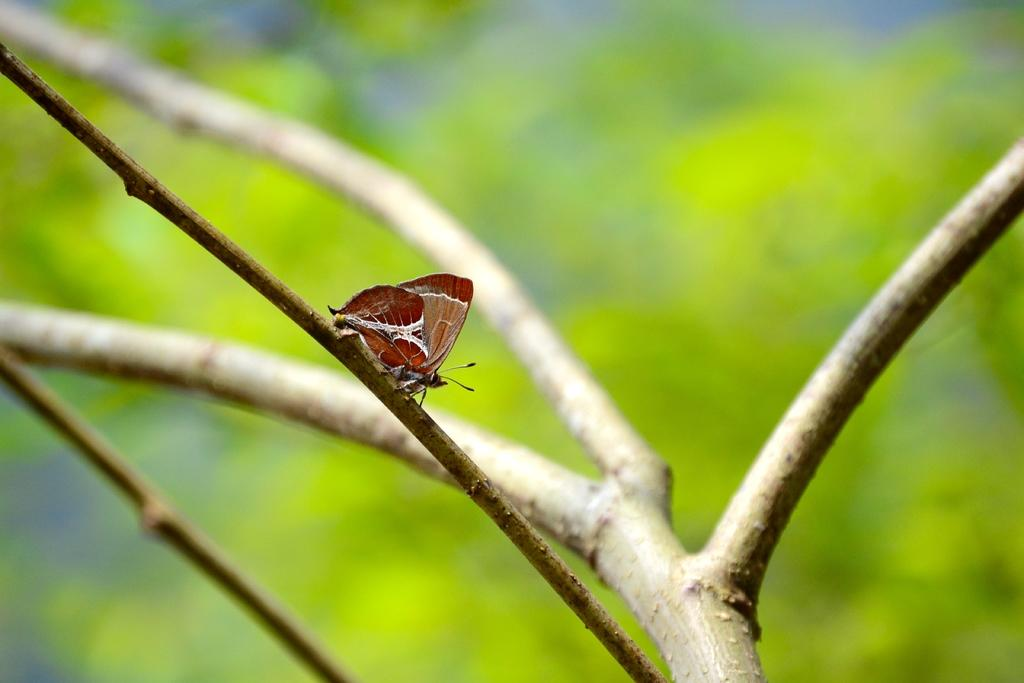What is the main subject of the image? There is a butterfly in the image. Where is the butterfly located? The butterfly is on the branch of a tree. Can you describe the background of the image? The background of the image is blurred. How many boats can be seen in the image? There are no boats present in the image; it features a butterfly on a tree branch. What finger is the butterfly using to hold onto the branch? Butterflies do not have fingers, and the image does not show the butterfly holding onto the branch with any appendages. 